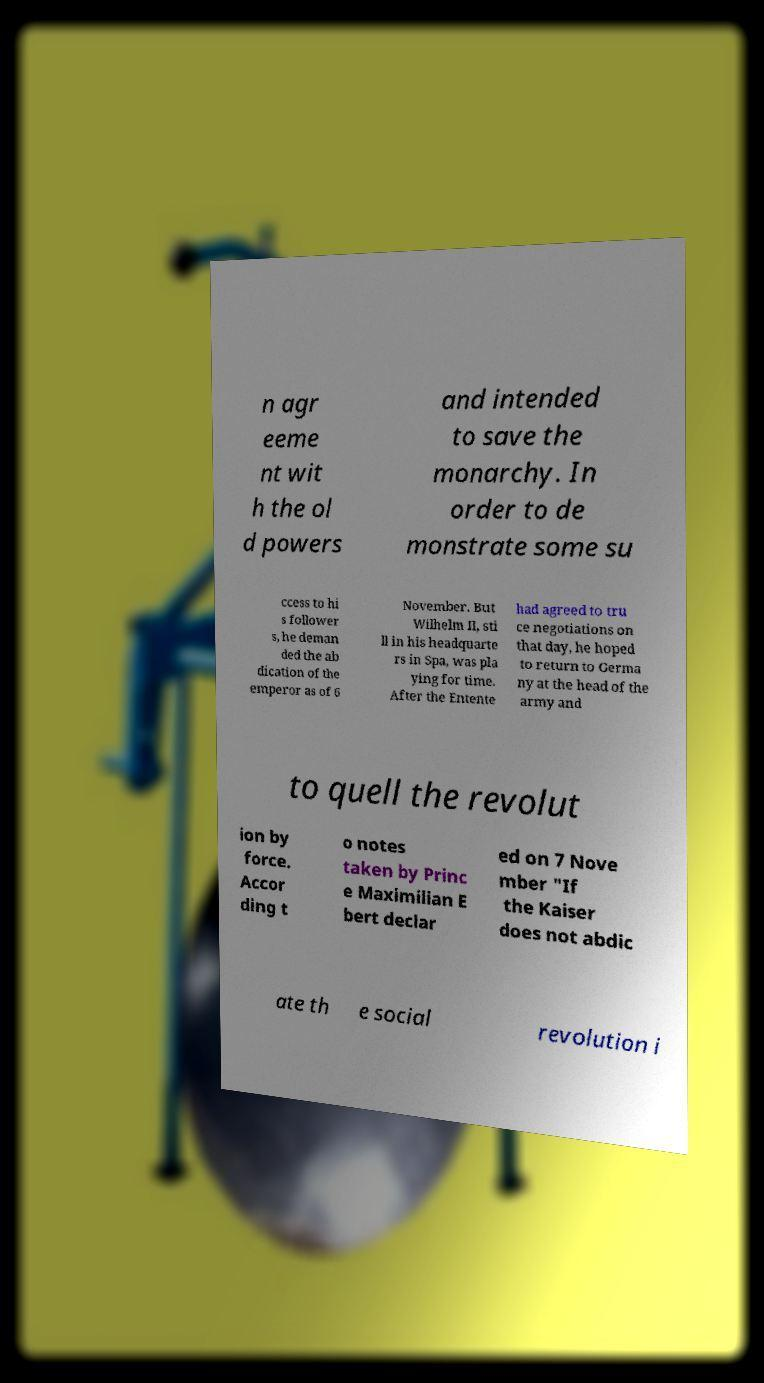Can you read and provide the text displayed in the image?This photo seems to have some interesting text. Can you extract and type it out for me? n agr eeme nt wit h the ol d powers and intended to save the monarchy. In order to de monstrate some su ccess to hi s follower s, he deman ded the ab dication of the emperor as of 6 November. But Wilhelm II, sti ll in his headquarte rs in Spa, was pla ying for time. After the Entente had agreed to tru ce negotiations on that day, he hoped to return to Germa ny at the head of the army and to quell the revolut ion by force. Accor ding t o notes taken by Princ e Maximilian E bert declar ed on 7 Nove mber "If the Kaiser does not abdic ate th e social revolution i 